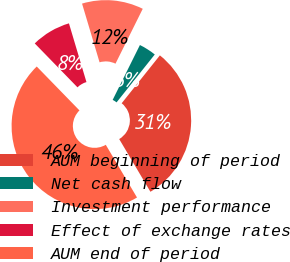Convert chart. <chart><loc_0><loc_0><loc_500><loc_500><pie_chart><fcel>AUM beginning of period<fcel>Net cash flow<fcel>Investment performance<fcel>Effect of exchange rates<fcel>AUM end of period<nl><fcel>30.77%<fcel>3.38%<fcel>11.95%<fcel>7.67%<fcel>46.23%<nl></chart> 